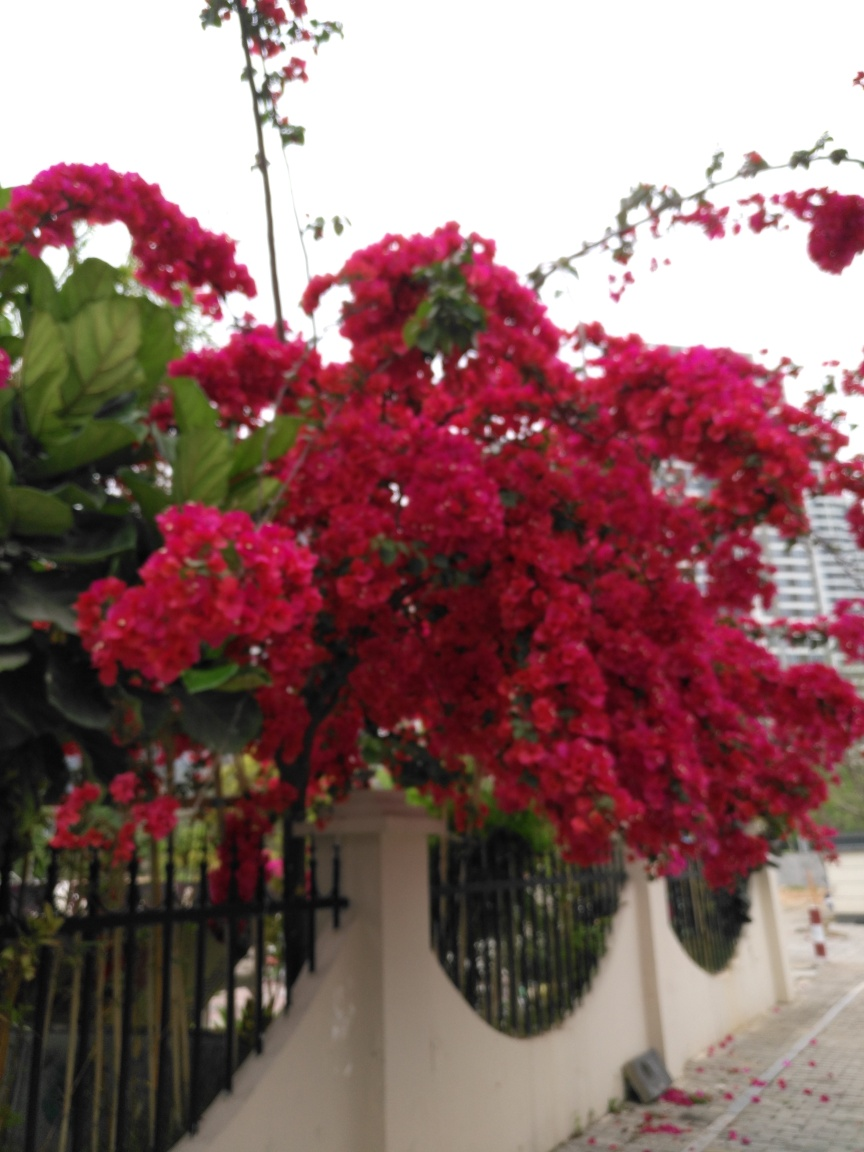Can you tell what type of flowers these are? The flowers in the image are bright red and appear to be from the Bougainvillea genus, which is known for its showy, paper-like structures that are often mistaken for petals. 